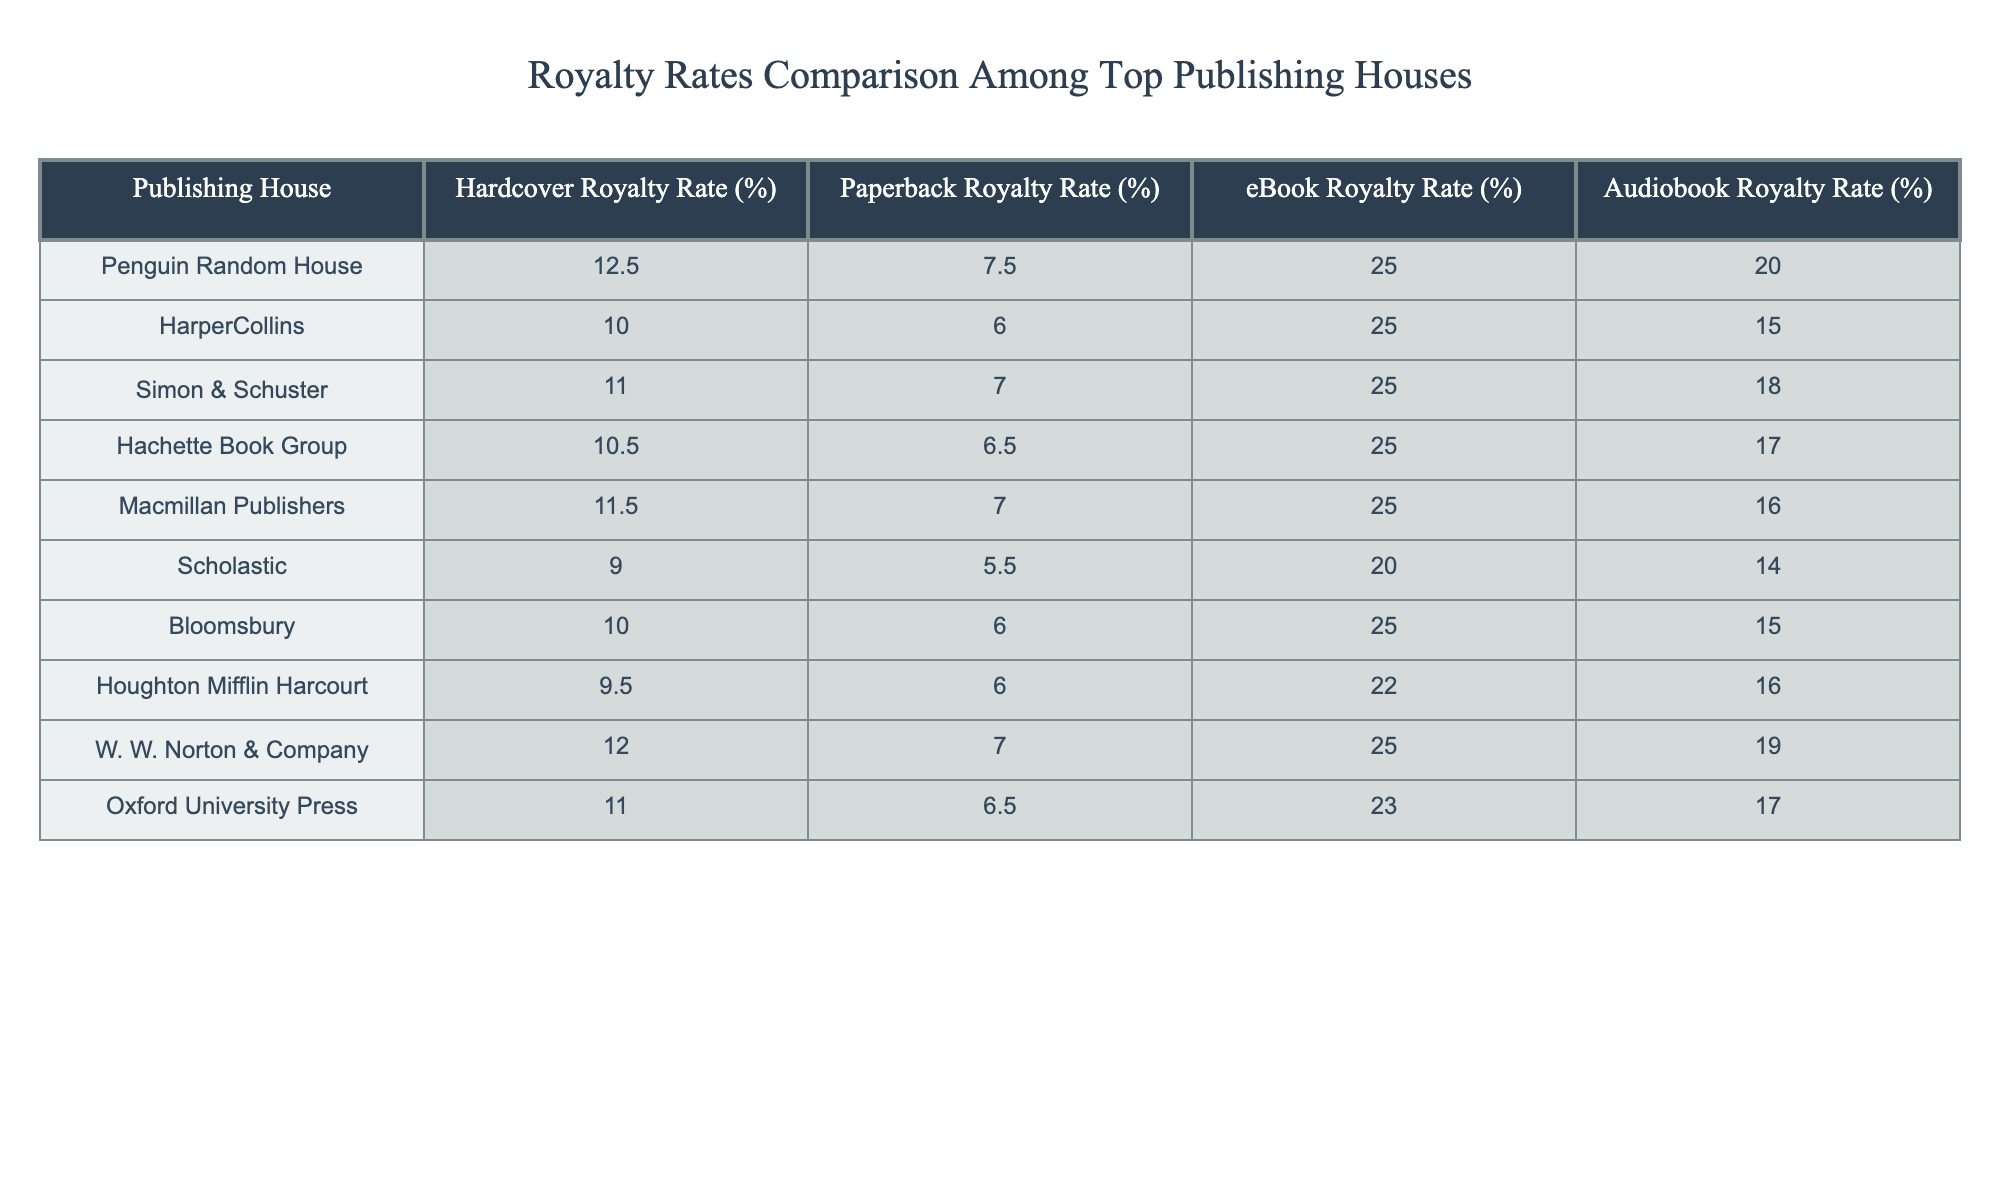What is the ebook royalty rate for HarperCollins? The table lists the ebook royalty rate for HarperCollins as 25%.
Answer: 25% Which publishing house has the highest hardcover royalty rate? The highest hardcover royalty rate in the table is 12.5%, attributed to Penguin Random House.
Answer: Penguin Random House What is the average paperback royalty rate among the listed publishing houses? Calculating the average: (7.5 + 6 + 7 + 6.5 + 7 + 5.5 + 6 + 6 + 7 + 6.5) = 64 and dividing by 10 gives an average of 6.4%.
Answer: 6.4% How does the audiobook royalty rate of Scholastic compare to that of Hachette Book Group? Scholastic's audiobook royalty rate is 14%, while Hachette Book Group's is 17%. Therefore, Hachette Book Group has a higher rate by 3%.
Answer: Hachette Book Group has a higher rate by 3% Is the hardcover royalty rate for Macmillan Publishers greater than for Simon & Schuster? The hardcover rate for Macmillan Publishers is 11.5%, while Simon & Schuster's is 11%, making Macmillan's rate greater.
Answer: Yes Which publishing house offers the lowest paperback royalty rate, and what is that rate? The lowest paperback royalty rate is offered by Scholastic at 5.5%.
Answer: Scholastic, 5.5% What is the difference in audiobook royalty rates between Penguin Random House and W. W. Norton & Company? Penguin Random House offers 20% while W. W. Norton & Company offers 19%. The difference is 1%.
Answer: 1% If you add the hardcover and paperback royalty rates for Houghton Mifflin Harcourt, what is the sum? The hardcover rate is 9.5% and the paperback rate is 6%, summing these gives 15.5%.
Answer: 15.5% Which publishing house has a higher ebook royalty rate: Oxford University Press or Macmillan Publishers? Oxford University Press has an ebook royalty rate of 23%, while Macmillan Publishers has 25%, indicating Macmillan offers a higher rate.
Answer: Macmillan Publishers What is the total of hardcover royalty rates for the two lowest-paying publishing houses? The two lowest-paying are Scholastic (9%) and Houghton Mifflin Harcourt (9.5%). Total= 9 + 9.5 = 18.5%.
Answer: 18.5% 